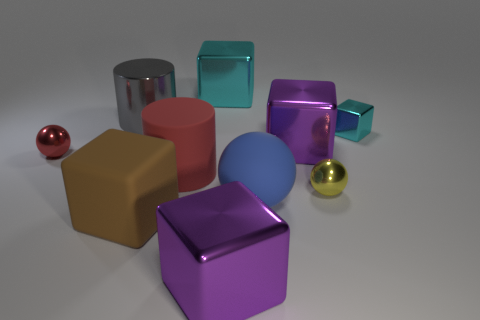Subtract all brown cubes. How many cubes are left? 4 Subtract all big matte blocks. How many blocks are left? 4 Subtract all cyan cylinders. Subtract all green blocks. How many cylinders are left? 2 Subtract all balls. How many objects are left? 7 Subtract 1 brown cubes. How many objects are left? 9 Subtract all blue balls. Subtract all large gray cylinders. How many objects are left? 8 Add 9 large red cylinders. How many large red cylinders are left? 10 Add 8 large purple matte cylinders. How many large purple matte cylinders exist? 8 